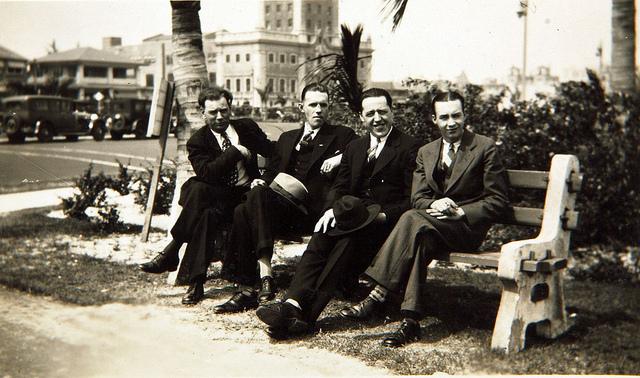Is it hard to tell the weather precipitation in the black and white photo?
Keep it brief. No. Is this foto black and  white?
Be succinct. Yes. What type of trees are in the photograph?
Short answer required. Palm. Is this taken in present day?
Concise answer only. No. 